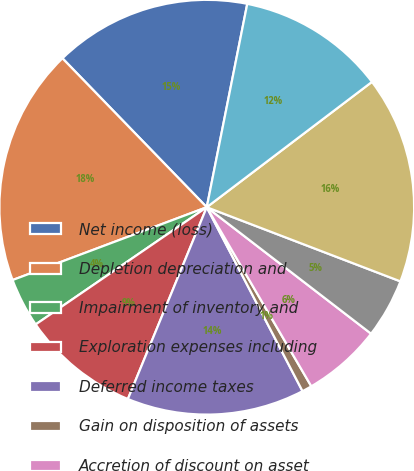Convert chart. <chart><loc_0><loc_0><loc_500><loc_500><pie_chart><fcel>Net income (loss)<fcel>Depletion depreciation and<fcel>Impairment of inventory and<fcel>Exploration expenses including<fcel>Deferred income taxes<fcel>Gain on disposition of assets<fcel>Accretion of discount on asset<fcel>Interest expense<fcel>Derivative related activity<fcel>Accounts receivable<nl><fcel>15.38%<fcel>18.46%<fcel>3.85%<fcel>9.23%<fcel>13.85%<fcel>0.77%<fcel>6.15%<fcel>4.62%<fcel>16.15%<fcel>11.54%<nl></chart> 